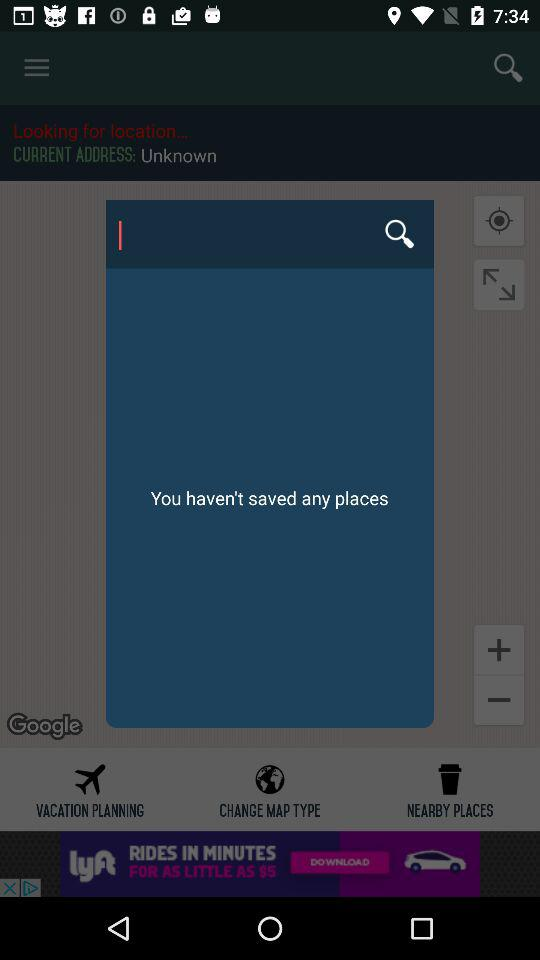How many places have you saved?
Answer the question using a single word or phrase. 0 